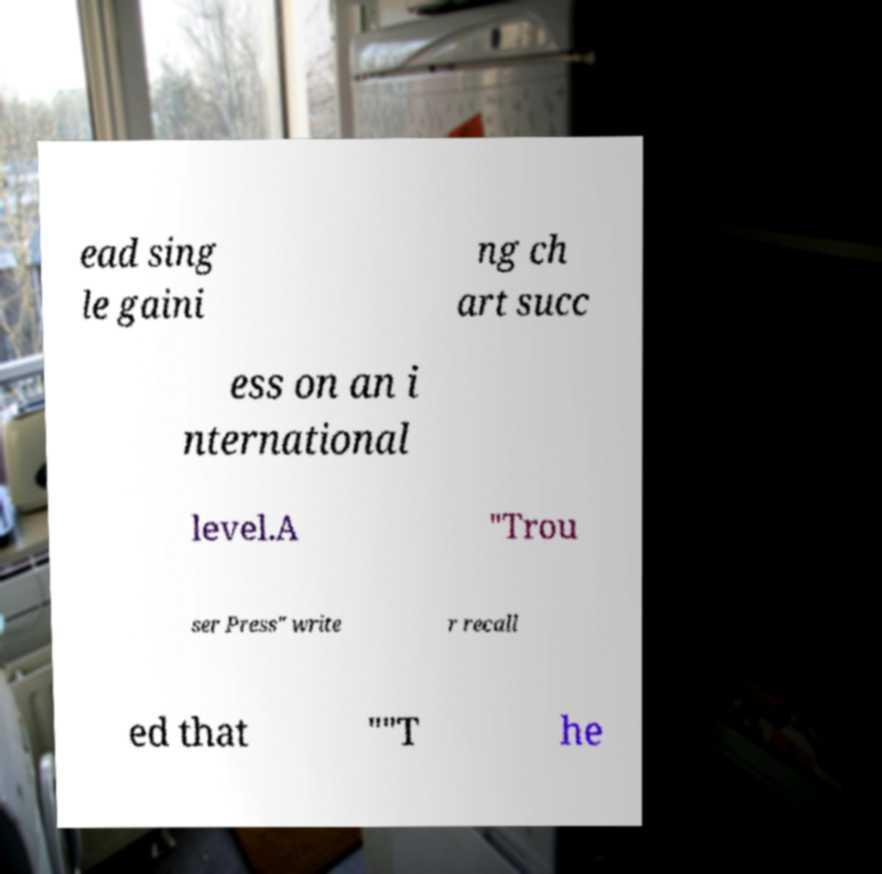Please identify and transcribe the text found in this image. ead sing le gaini ng ch art succ ess on an i nternational level.A "Trou ser Press" write r recall ed that ""T he 